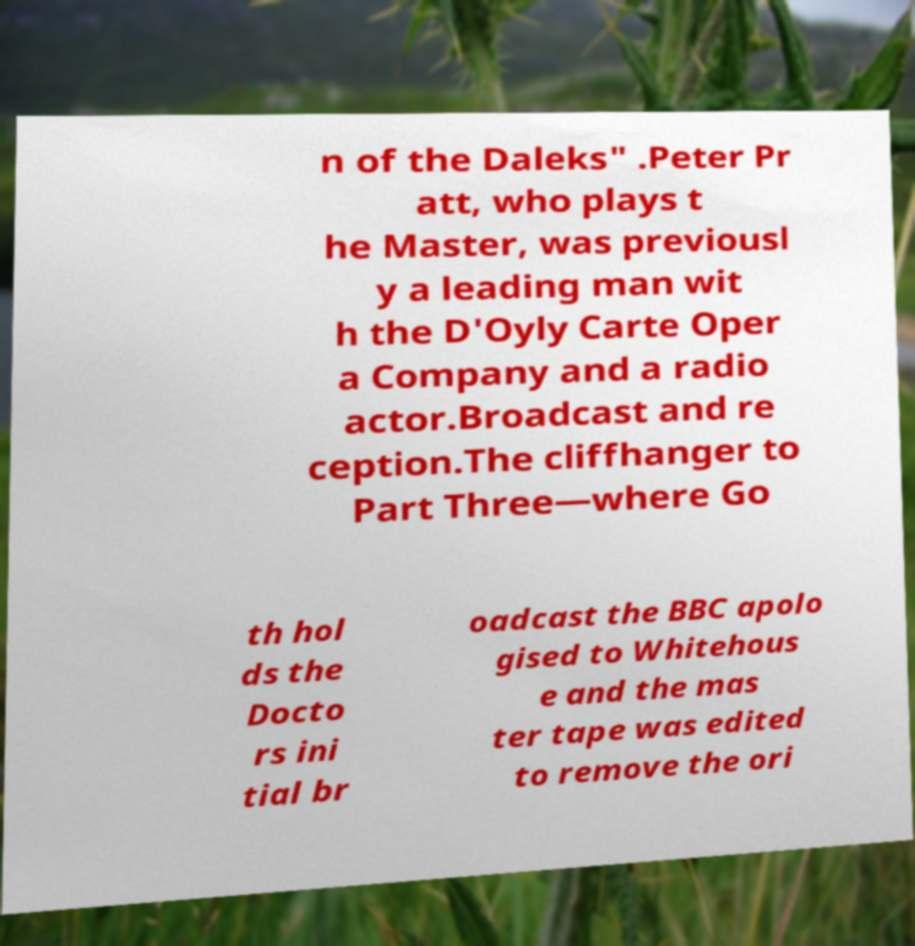Could you extract and type out the text from this image? n of the Daleks" .Peter Pr att, who plays t he Master, was previousl y a leading man wit h the D'Oyly Carte Oper a Company and a radio actor.Broadcast and re ception.The cliffhanger to Part Three—where Go th hol ds the Docto rs ini tial br oadcast the BBC apolo gised to Whitehous e and the mas ter tape was edited to remove the ori 